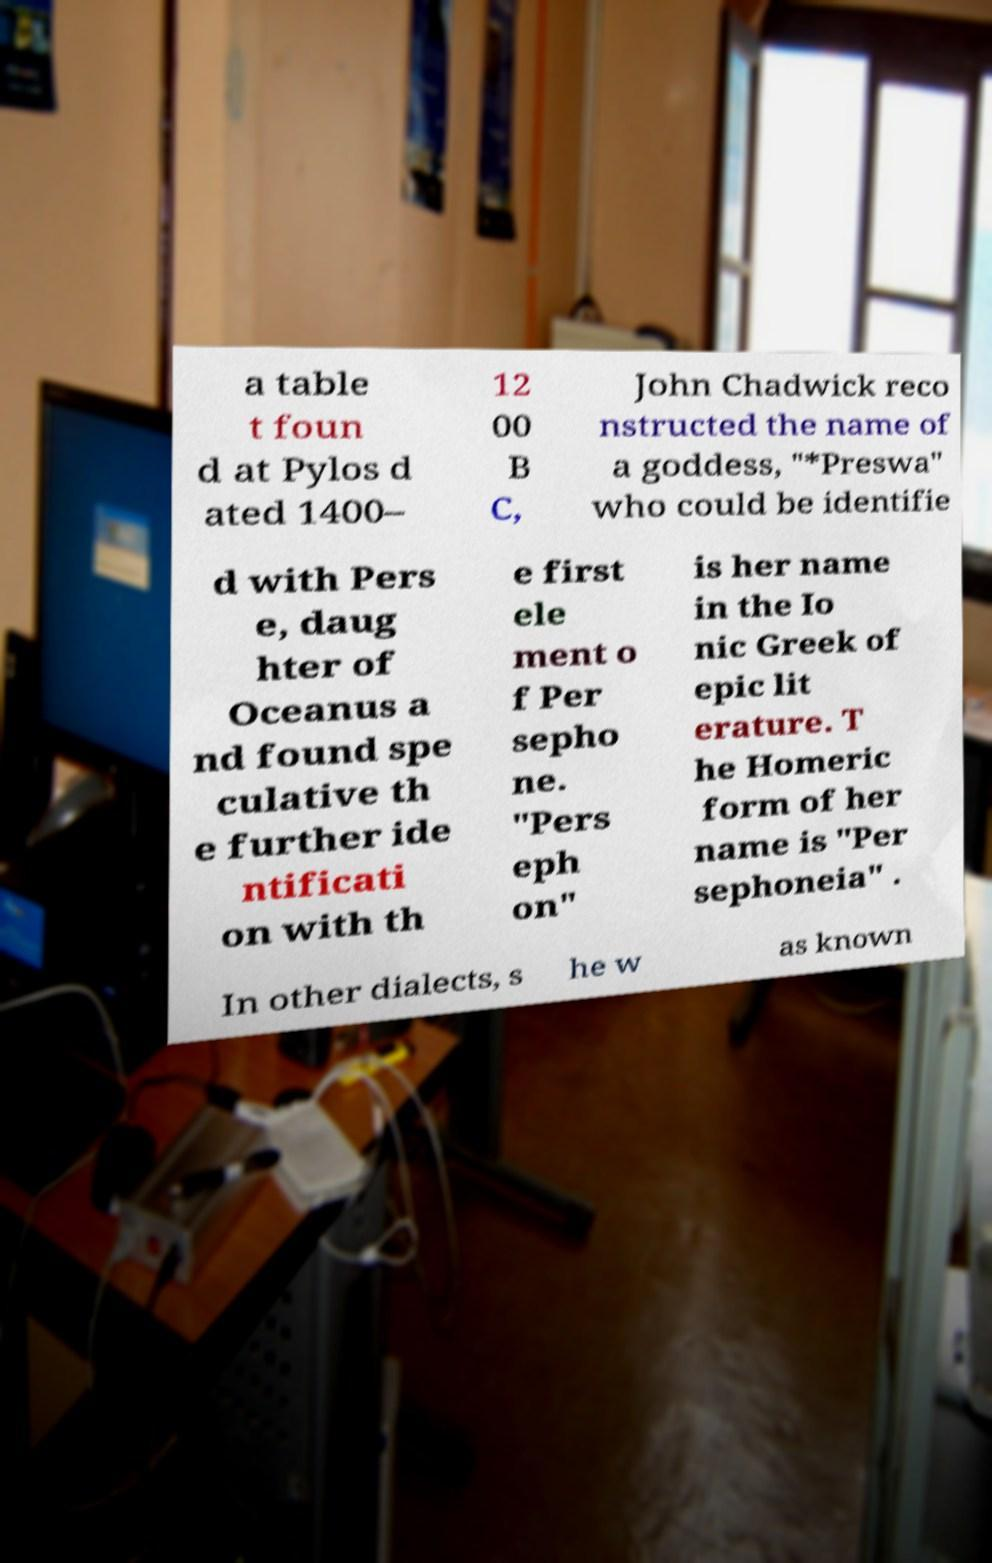Could you extract and type out the text from this image? a table t foun d at Pylos d ated 1400– 12 00 B C, John Chadwick reco nstructed the name of a goddess, "*Preswa" who could be identifie d with Pers e, daug hter of Oceanus a nd found spe culative th e further ide ntificati on with th e first ele ment o f Per sepho ne. "Pers eph on" is her name in the Io nic Greek of epic lit erature. T he Homeric form of her name is "Per sephoneia" . In other dialects, s he w as known 